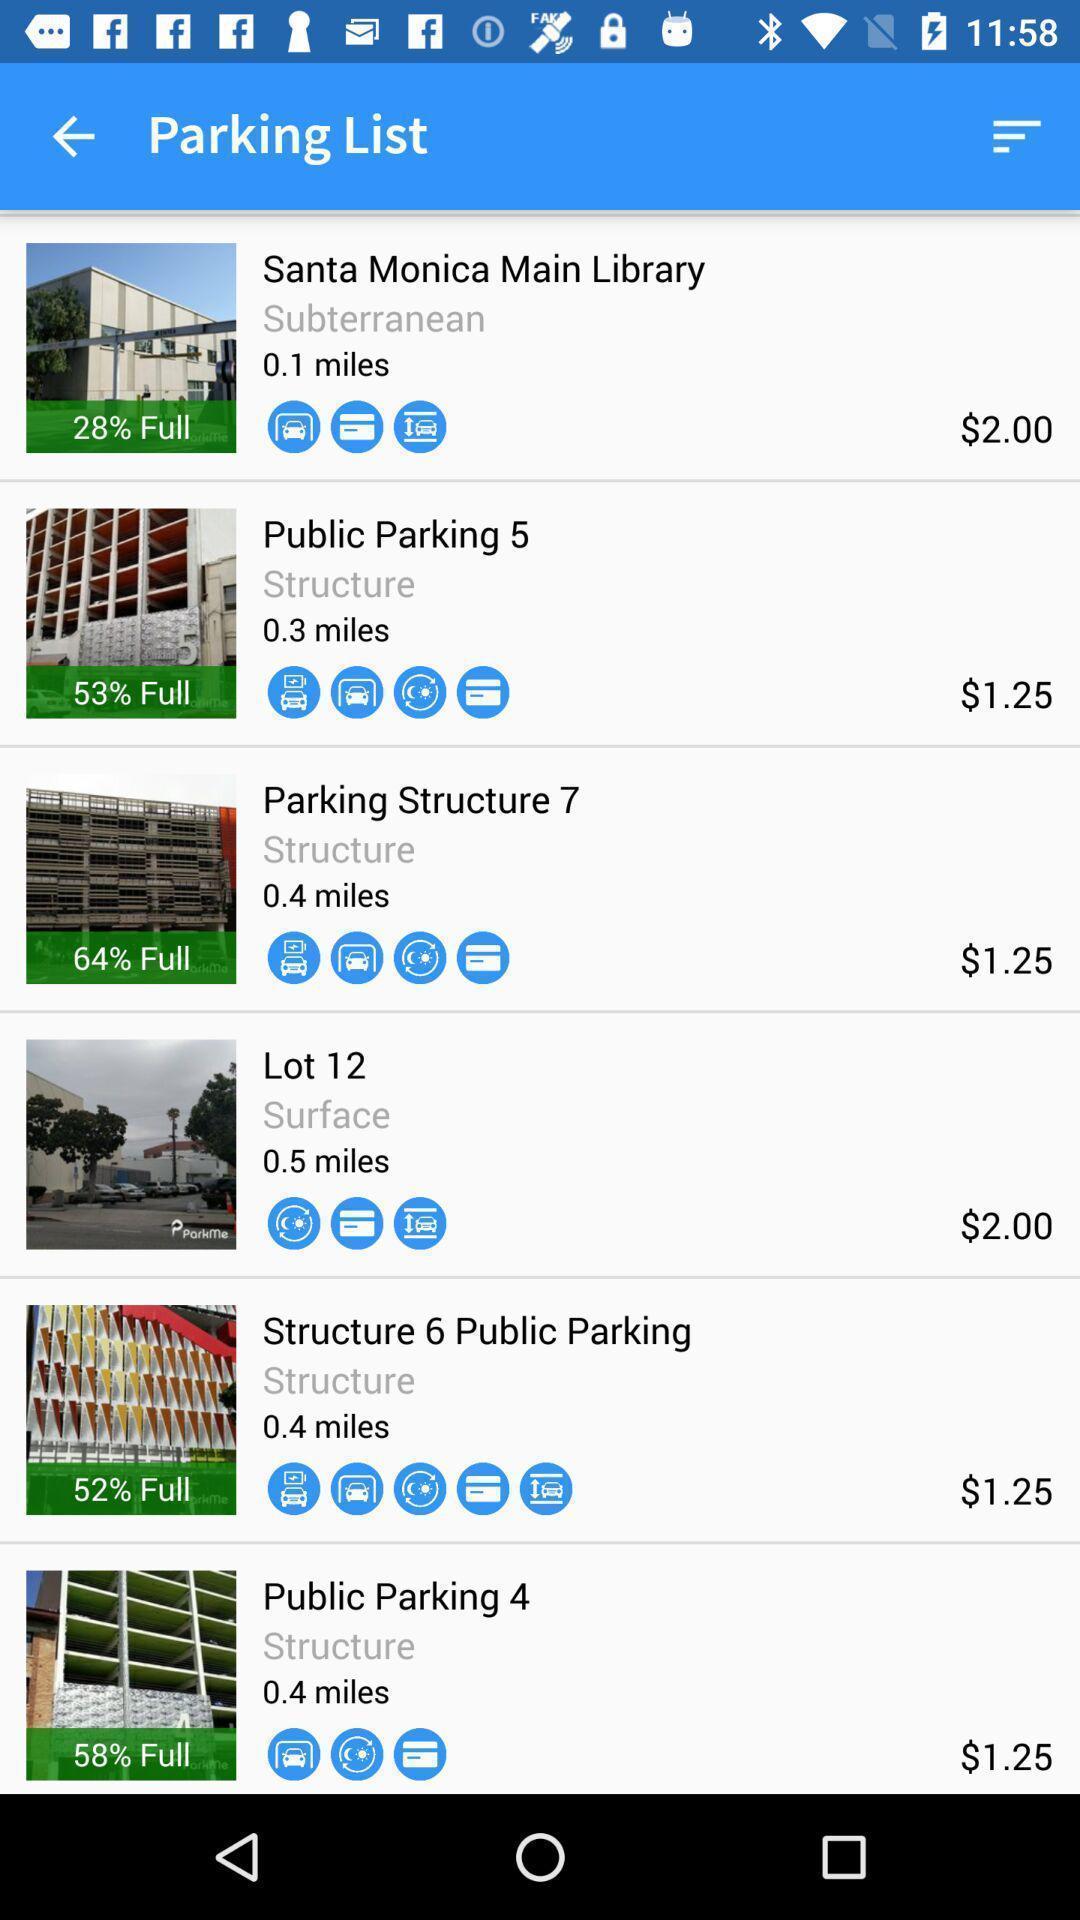Provide a description of this screenshot. Screen displaying list of building images with price and distance. 